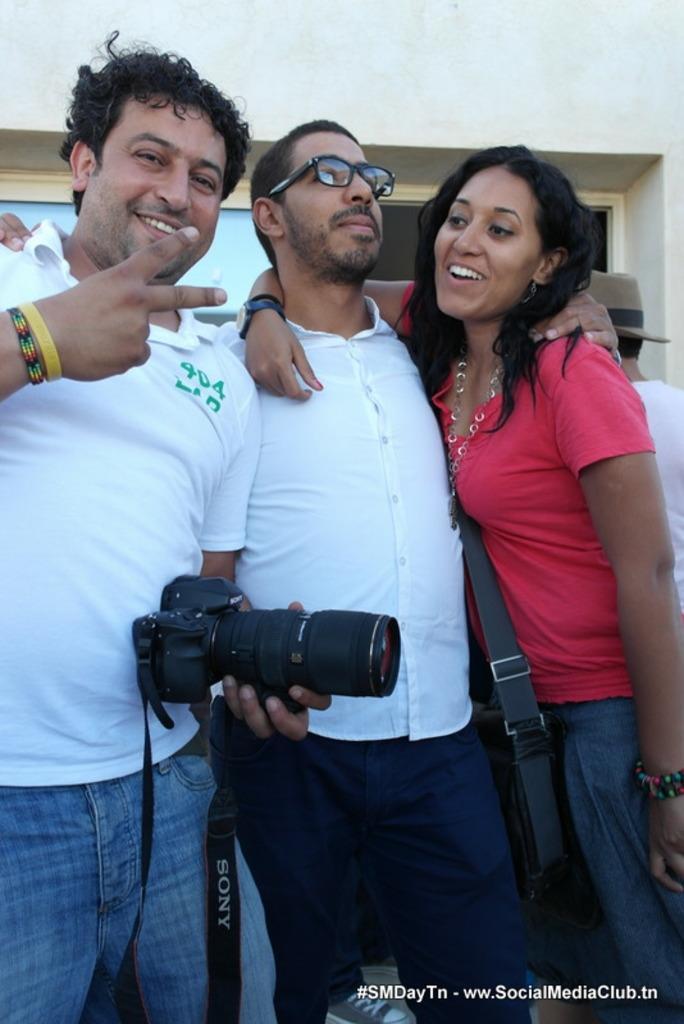In one or two sentences, can you explain what this image depicts? This image consists of three paper. Two men and one woman. She is on the right side, the man who is on the left side is holding camera. 